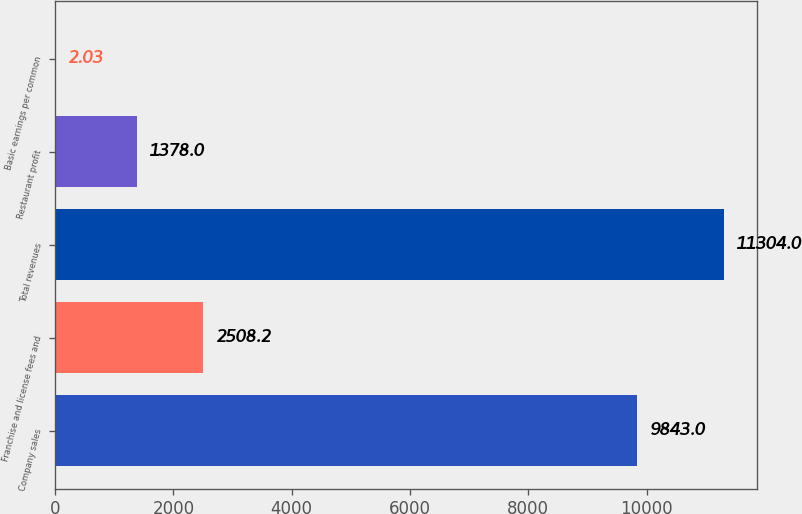<chart> <loc_0><loc_0><loc_500><loc_500><bar_chart><fcel>Company sales<fcel>Franchise and license fees and<fcel>Total revenues<fcel>Restaurant profit<fcel>Basic earnings per common<nl><fcel>9843<fcel>2508.2<fcel>11304<fcel>1378<fcel>2.03<nl></chart> 